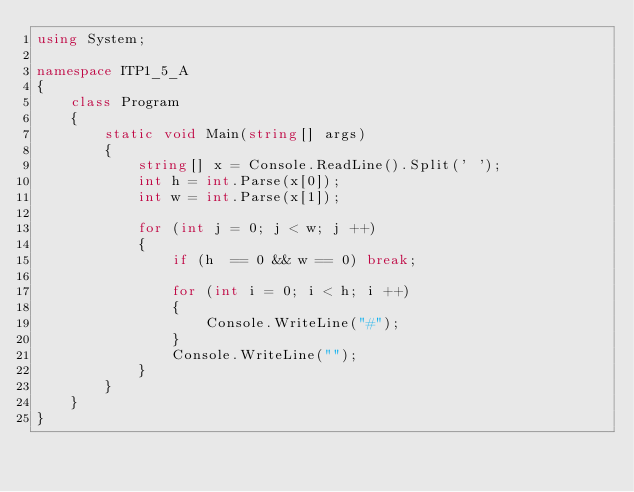<code> <loc_0><loc_0><loc_500><loc_500><_C#_>using System;

namespace ITP1_5_A
{
    class Program
    {
        static void Main(string[] args)
        {
            string[] x = Console.ReadLine().Split(' ');
            int h = int.Parse(x[0]);
            int w = int.Parse(x[1]);
            
            for (int j = 0; j < w; j ++)
            {
                if (h  == 0 && w == 0) break;
                
                for (int i = 0; i < h; i ++)
                {
                    Console.WriteLine("#");
                }
                Console.WriteLine("");
            }
        }
    }
}
</code> 